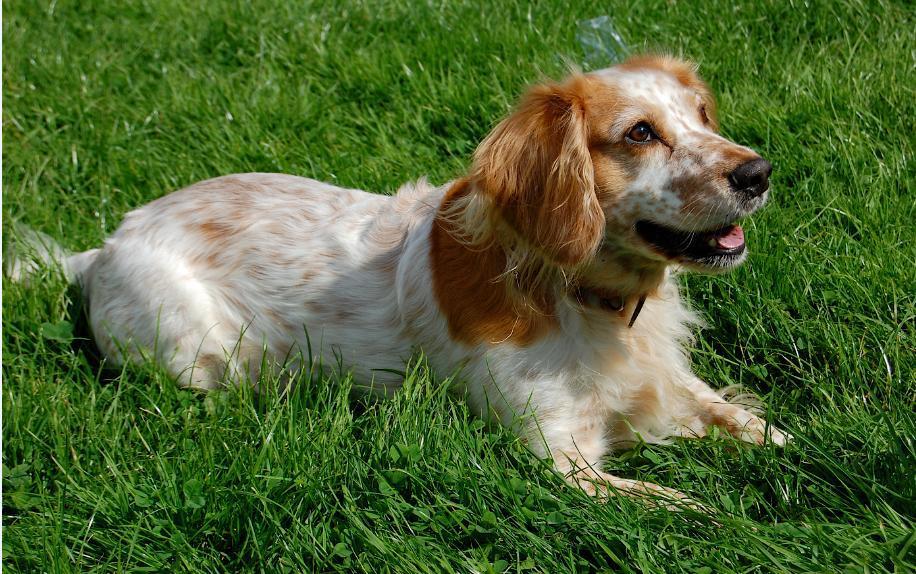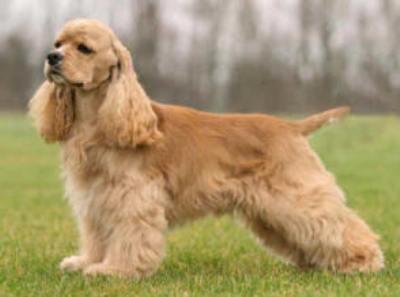The first image is the image on the left, the second image is the image on the right. Evaluate the accuracy of this statement regarding the images: "Right image shows a solid colored golden spaniel standing in profile on grass.". Is it true? Answer yes or no. Yes. 